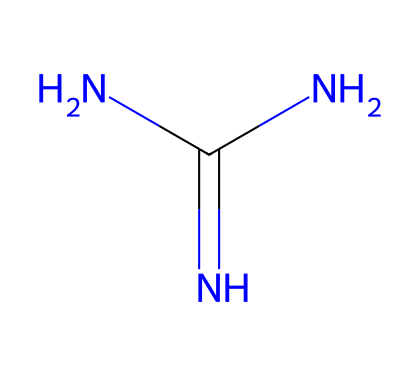What is the functional group present in guanidine? The guanidine structure contains a carbon atom bonded to three nitrogen atoms, indicating the presence of the guanidine functional group, which is characterized by the arrangement of these two types of atoms.
Answer: guanidine How many nitrogen atoms are in guanidine? By analyzing the SMILES representation, we can see there are three nitrogen atoms in the structure, denoted by "N" appearing three times in the formula.
Answer: three What is the oxidation state of carbon in guanidine? The carbon atom in guanidine is bonded to two nitrogen atoms through a double bond and one through a simple bond, with no other elements attached, which gives it an oxidation state of -2 based on its overall bonding.
Answer: -2 Is guanidine a strong base? Guanidine is classified as a strong superbase due to its ability to accept protons readily, owing to the presence of highly basic nitrogen atoms in its structure.
Answer: yes What type of bonding is involved in guanidine's structure? The chemical structure of guanidine involves covalent bonding, as all the atoms are combined by shared electron pairs among the nitrogen and carbon atoms.
Answer: covalent Can guanidine form salts? Guanidine can form salts through its basic nature, allowing it to react with acids to create guanidine salts, thus confirming its capacity for such reactions.
Answer: yes 